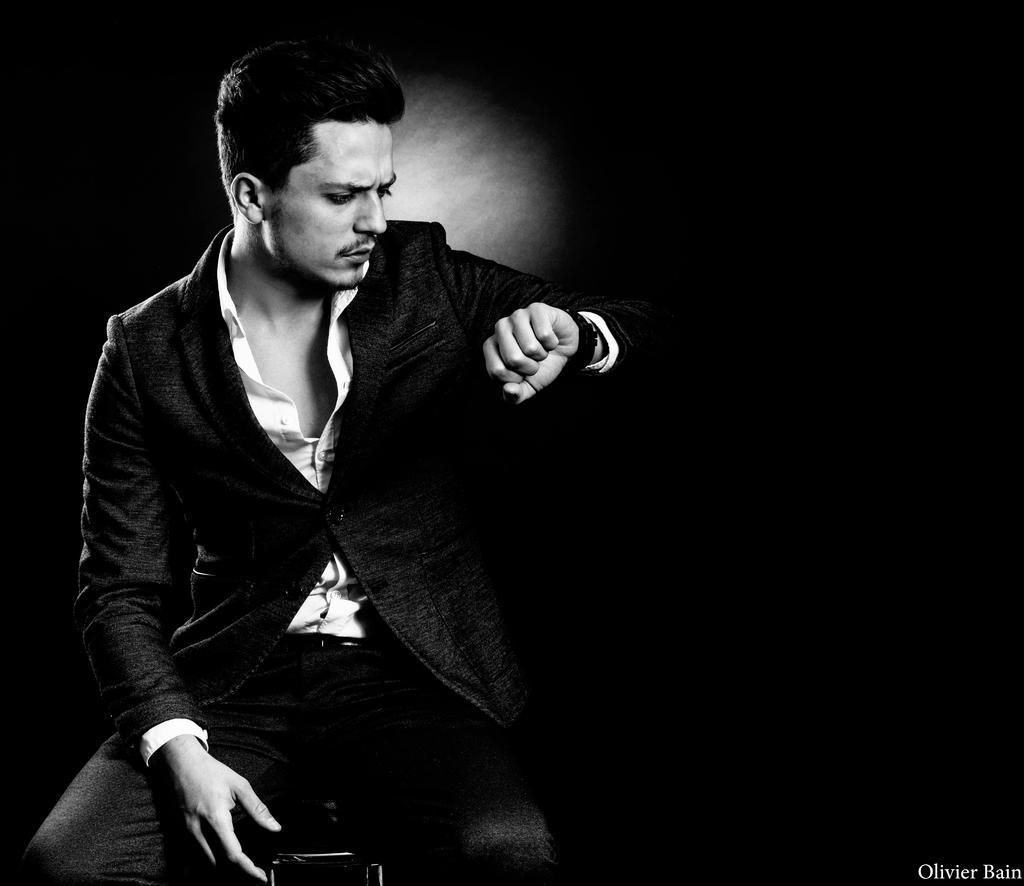Please provide a concise description of this image. This is a black and white image. On the left side of the image a man is sitting on a table. At the bottom right corner we can see some text. In the background the image is dark 